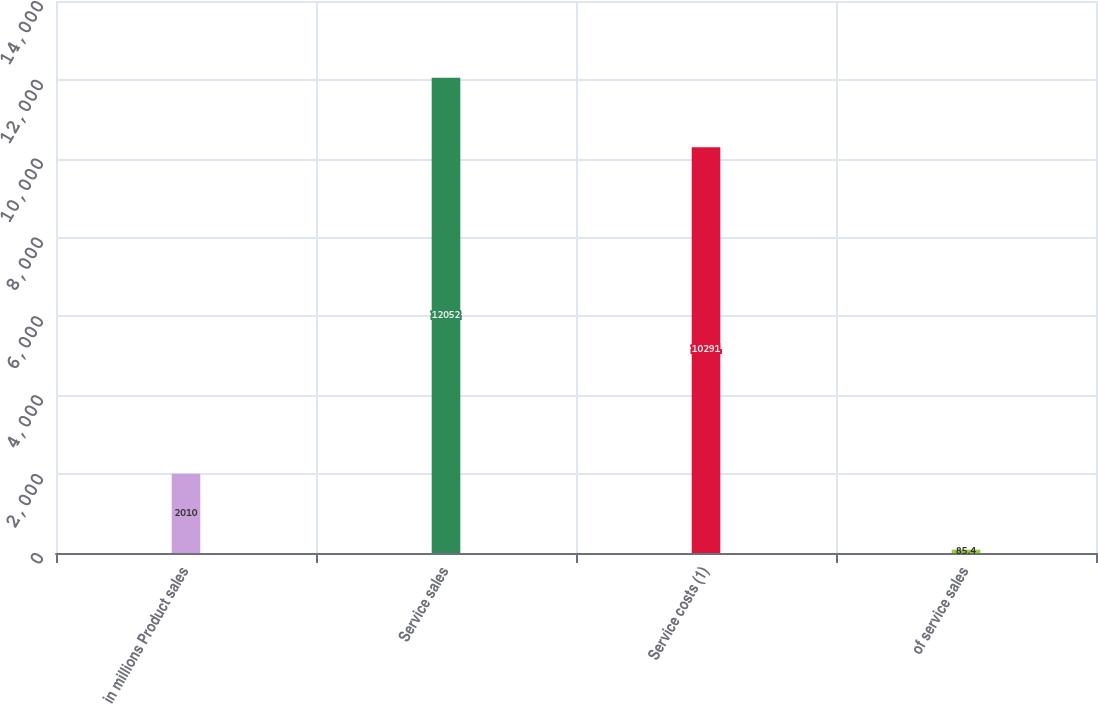Convert chart to OTSL. <chart><loc_0><loc_0><loc_500><loc_500><bar_chart><fcel>in millions Product sales<fcel>Service sales<fcel>Service costs (1)<fcel>of service sales<nl><fcel>2010<fcel>12052<fcel>10291<fcel>85.4<nl></chart> 